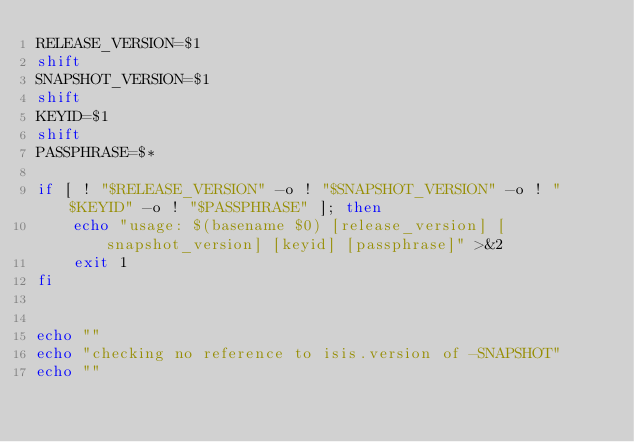<code> <loc_0><loc_0><loc_500><loc_500><_Bash_>RELEASE_VERSION=$1
shift
SNAPSHOT_VERSION=$1
shift
KEYID=$1
shift
PASSPHRASE=$*

if [ ! "$RELEASE_VERSION" -o ! "$SNAPSHOT_VERSION" -o ! "$KEYID" -o ! "$PASSPHRASE" ]; then
    echo "usage: $(basename $0) [release_version] [snapshot_version] [keyid] [passphrase]" >&2
    exit 1
fi


echo ""
echo "checking no reference to isis.version of -SNAPSHOT"
echo ""</code> 